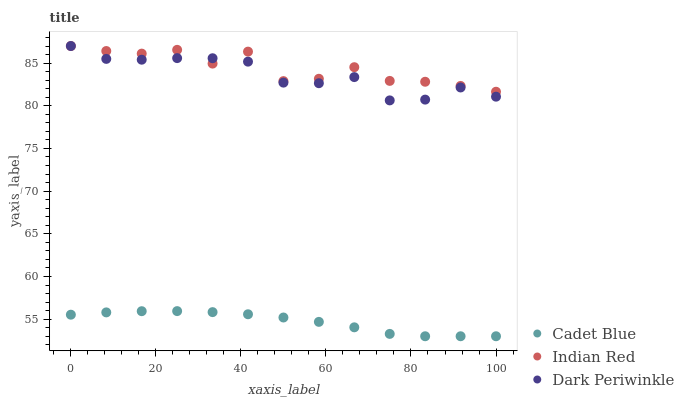Does Cadet Blue have the minimum area under the curve?
Answer yes or no. Yes. Does Indian Red have the maximum area under the curve?
Answer yes or no. Yes. Does Dark Periwinkle have the minimum area under the curve?
Answer yes or no. No. Does Dark Periwinkle have the maximum area under the curve?
Answer yes or no. No. Is Cadet Blue the smoothest?
Answer yes or no. Yes. Is Indian Red the roughest?
Answer yes or no. Yes. Is Dark Periwinkle the smoothest?
Answer yes or no. No. Is Dark Periwinkle the roughest?
Answer yes or no. No. Does Cadet Blue have the lowest value?
Answer yes or no. Yes. Does Dark Periwinkle have the lowest value?
Answer yes or no. No. Does Indian Red have the highest value?
Answer yes or no. Yes. Is Cadet Blue less than Indian Red?
Answer yes or no. Yes. Is Dark Periwinkle greater than Cadet Blue?
Answer yes or no. Yes. Does Dark Periwinkle intersect Indian Red?
Answer yes or no. Yes. Is Dark Periwinkle less than Indian Red?
Answer yes or no. No. Is Dark Periwinkle greater than Indian Red?
Answer yes or no. No. Does Cadet Blue intersect Indian Red?
Answer yes or no. No. 